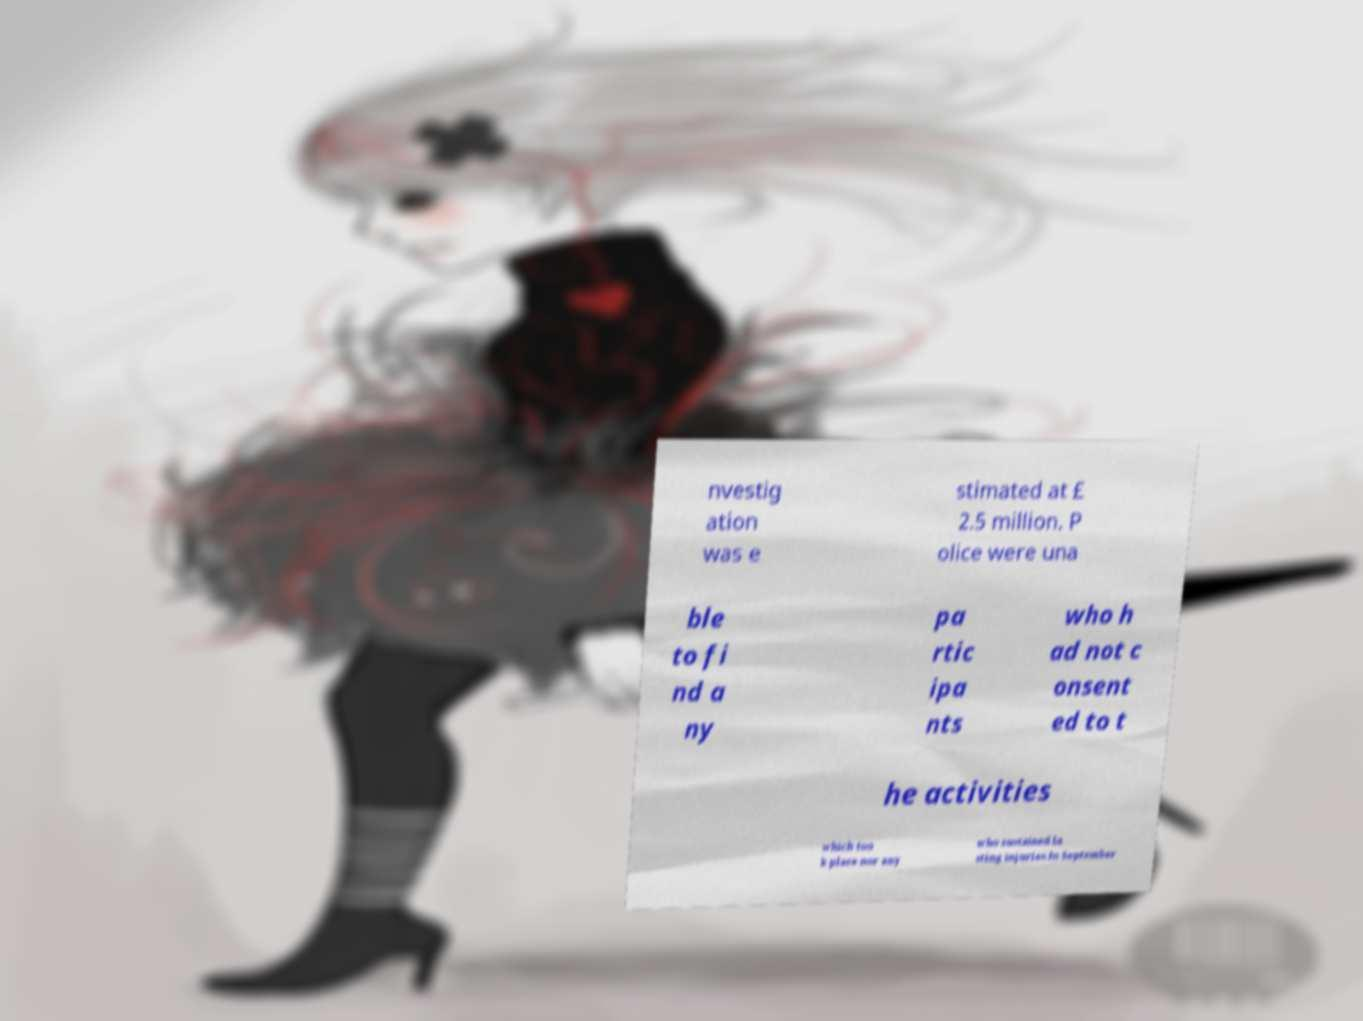Can you accurately transcribe the text from the provided image for me? nvestig ation was e stimated at £ 2.5 million. P olice were una ble to fi nd a ny pa rtic ipa nts who h ad not c onsent ed to t he activities which too k place nor any who sustained la sting injuries.In September 